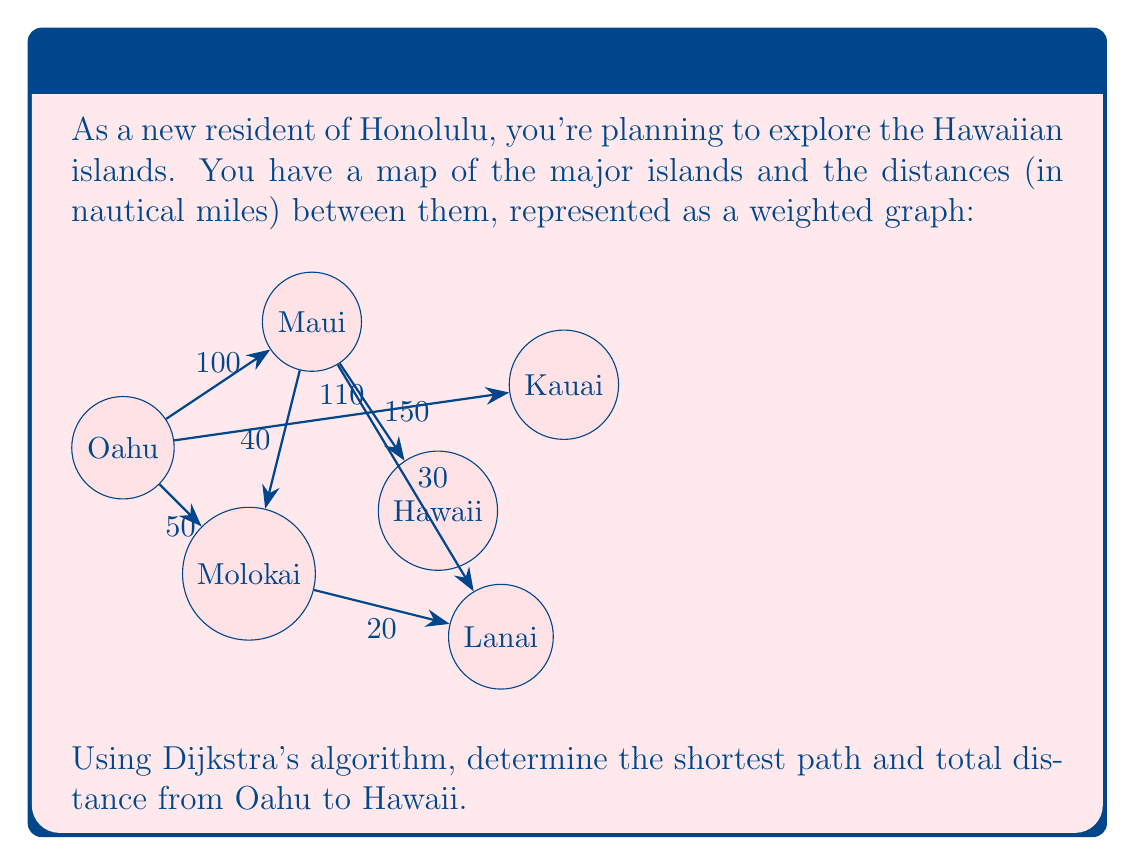Provide a solution to this math problem. Let's apply Dijkstra's algorithm to find the shortest path from Oahu to Hawaii:

1) Initialize:
   - Set distance to Oahu (start) as 0
   - Set distances to all other islands as infinity
   - Set all islands as unvisited

2) For the current island (starting with Oahu), consider all unvisited neighbors and calculate their tentative distances:
   - Oahu to Maui: 100
   - Oahu to Kauai: 110
   - Oahu to Molokai: 50

3) Mark Oahu as visited. Molokai now has the smallest tentative distance (50), so we move to Molokai.

4) From Molokai:
   - Molokai to Lanai: 50 + 20 = 70

5) Mark Molokai as visited. Maui has the next smallest tentative distance (100), so we move to Maui.

6) From Maui:
   - Update Lanai: min(70, 100 + 30) = 70
   - Maui to Hawaii: 100 + 150 = 250

7) Mark Maui as visited. Lanai has the next smallest tentative distance (70), but it doesn't lead to any unvisited islands.

8) The only unvisited islands left are Kauai (110) and Hawaii (250). Hawaii is our destination, so we're done.

The shortest path is Oahu → Maui → Hawaii, with a total distance of 250 nautical miles.
Answer: Oahu → Maui → Hawaii, 250 nautical miles 